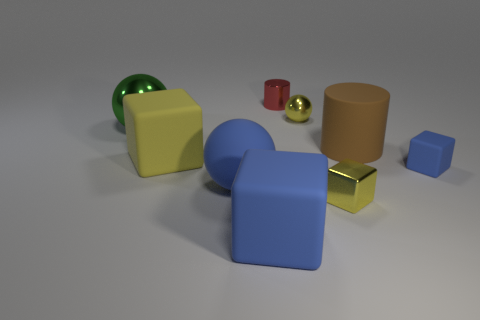Is the blue ball that is to the left of the big matte cylinder made of the same material as the cylinder that is in front of the tiny red thing? Based on the image, the blue ball to the left of the large matte cylinder appears to have a similar surface texture and matte finish, which suggests that it could be made of the same or a similar material as the matte cylinder located in front of the tiny red object. 